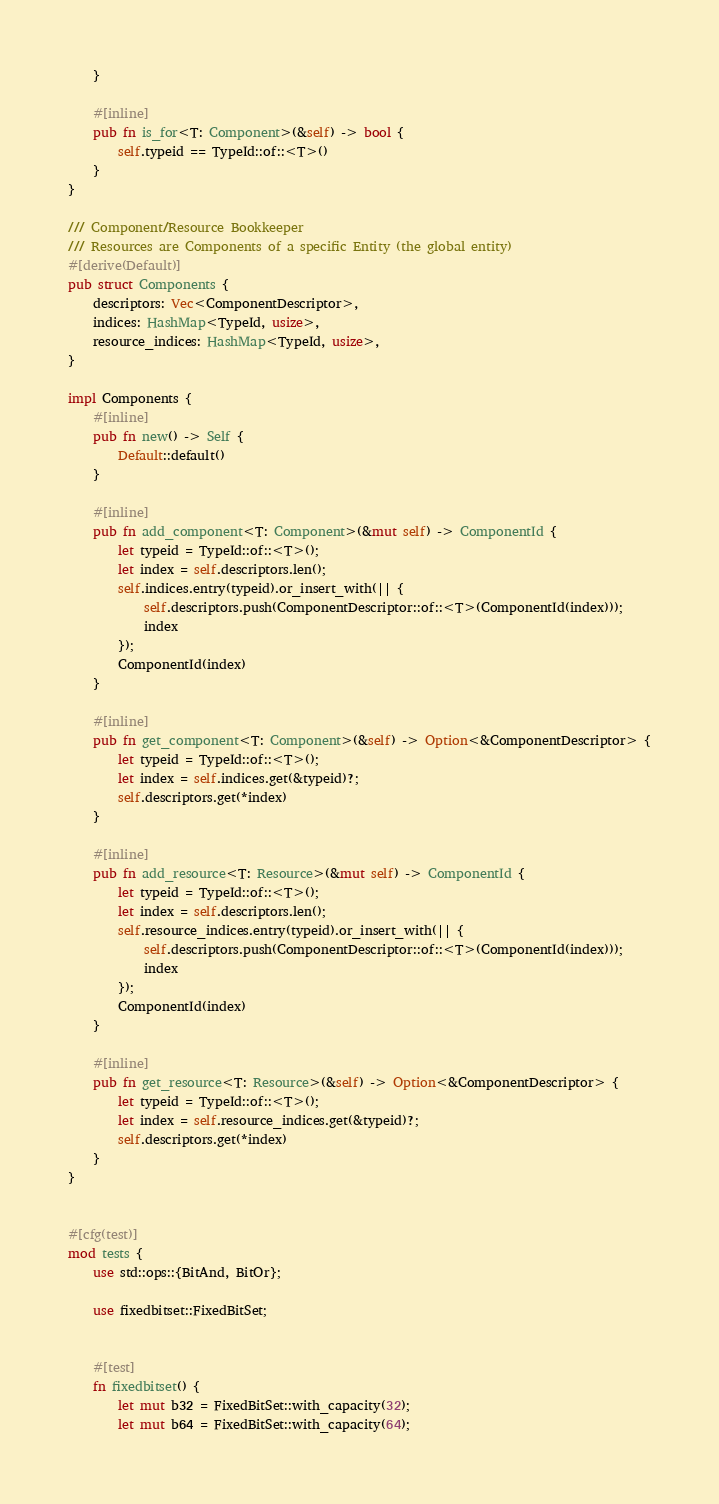Convert code to text. <code><loc_0><loc_0><loc_500><loc_500><_Rust_>    }

    #[inline]
    pub fn is_for<T: Component>(&self) -> bool {
        self.typeid == TypeId::of::<T>()
    }
}

/// Component/Resource Bookkeeper
/// Resources are Components of a specific Entity (the global entity)
#[derive(Default)]
pub struct Components {
    descriptors: Vec<ComponentDescriptor>,
    indices: HashMap<TypeId, usize>,
    resource_indices: HashMap<TypeId, usize>,
}

impl Components {
    #[inline]
    pub fn new() -> Self {
        Default::default()
    }

    #[inline]
    pub fn add_component<T: Component>(&mut self) -> ComponentId {
        let typeid = TypeId::of::<T>();
        let index = self.descriptors.len();
        self.indices.entry(typeid).or_insert_with(|| {
            self.descriptors.push(ComponentDescriptor::of::<T>(ComponentId(index)));
            index
        });
        ComponentId(index)
    }

    #[inline]
    pub fn get_component<T: Component>(&self) -> Option<&ComponentDescriptor> {
        let typeid = TypeId::of::<T>();
        let index = self.indices.get(&typeid)?;
        self.descriptors.get(*index)
    }

    #[inline]
    pub fn add_resource<T: Resource>(&mut self) -> ComponentId {
        let typeid = TypeId::of::<T>();
        let index = self.descriptors.len();
        self.resource_indices.entry(typeid).or_insert_with(|| {
            self.descriptors.push(ComponentDescriptor::of::<T>(ComponentId(index)));
            index
        });
        ComponentId(index)
    }

    #[inline]
    pub fn get_resource<T: Resource>(&self) -> Option<&ComponentDescriptor> {
        let typeid = TypeId::of::<T>();
        let index = self.resource_indices.get(&typeid)?;
        self.descriptors.get(*index)
    }
}


#[cfg(test)]
mod tests {
    use std::ops::{BitAnd, BitOr};

    use fixedbitset::FixedBitSet;


    #[test]
    fn fixedbitset() {
        let mut b32 = FixedBitSet::with_capacity(32);
        let mut b64 = FixedBitSet::with_capacity(64);</code> 